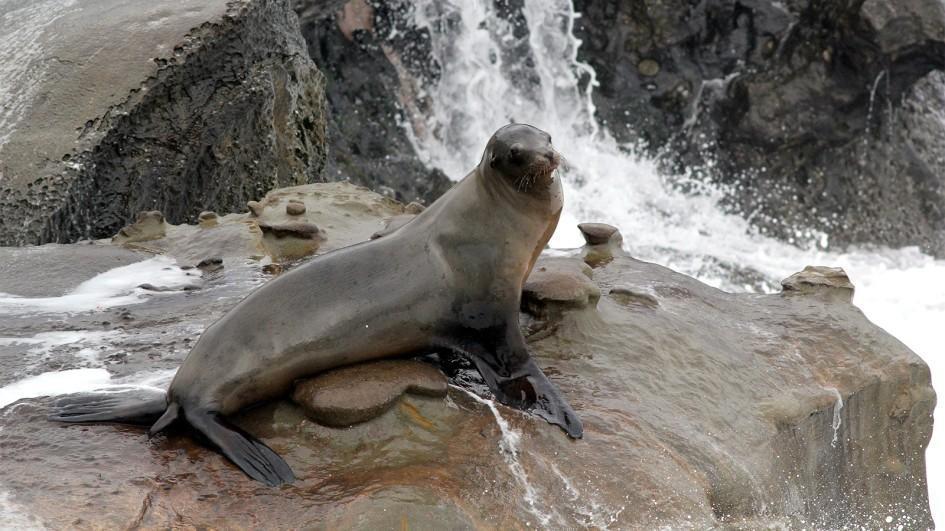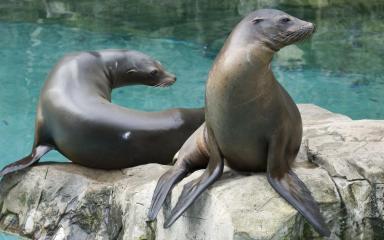The first image is the image on the left, the second image is the image on the right. Analyze the images presented: Is the assertion "There is at least one seal resting on a solid surface" valid? Answer yes or no. Yes. 